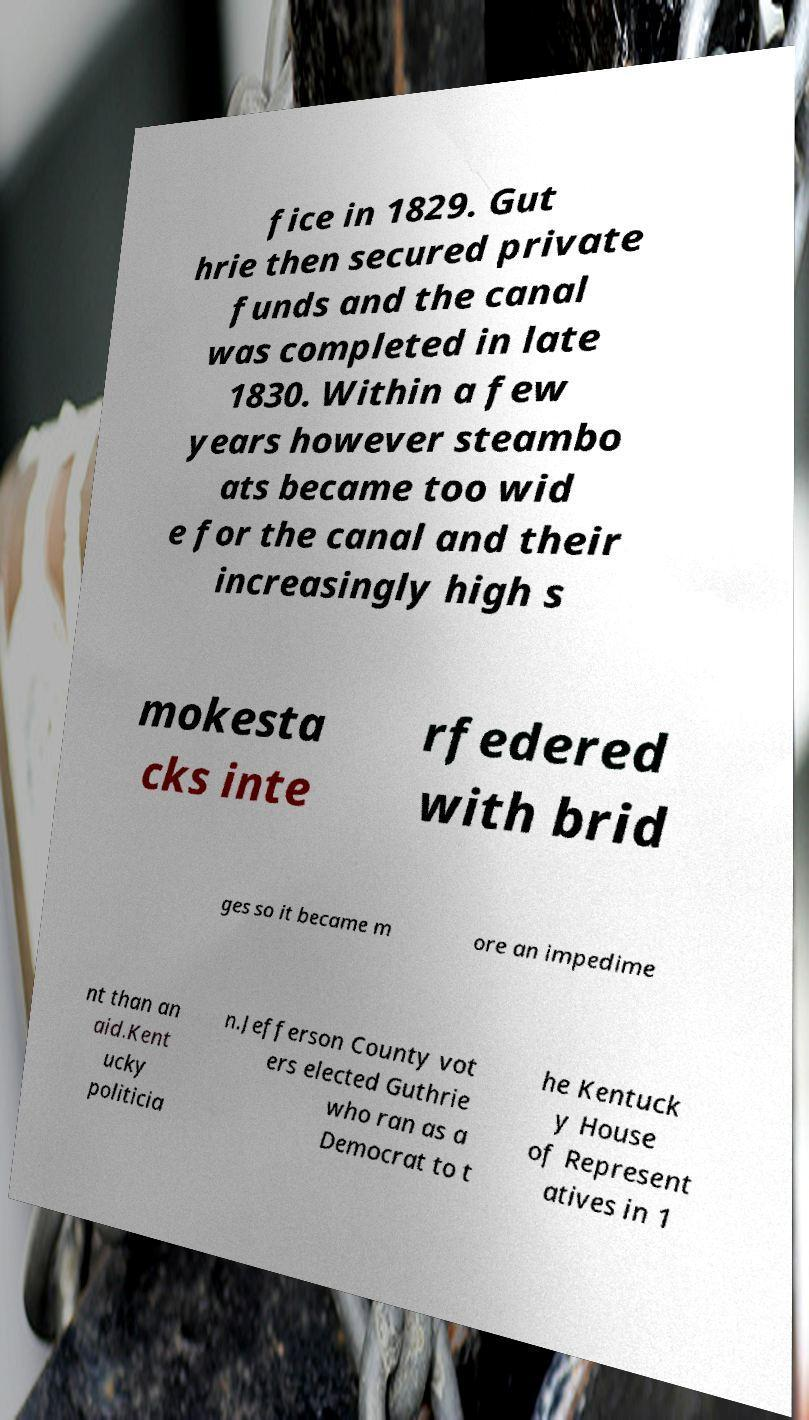I need the written content from this picture converted into text. Can you do that? fice in 1829. Gut hrie then secured private funds and the canal was completed in late 1830. Within a few years however steambo ats became too wid e for the canal and their increasingly high s mokesta cks inte rfedered with brid ges so it became m ore an impedime nt than an aid.Kent ucky politicia n.Jefferson County vot ers elected Guthrie who ran as a Democrat to t he Kentuck y House of Represent atives in 1 